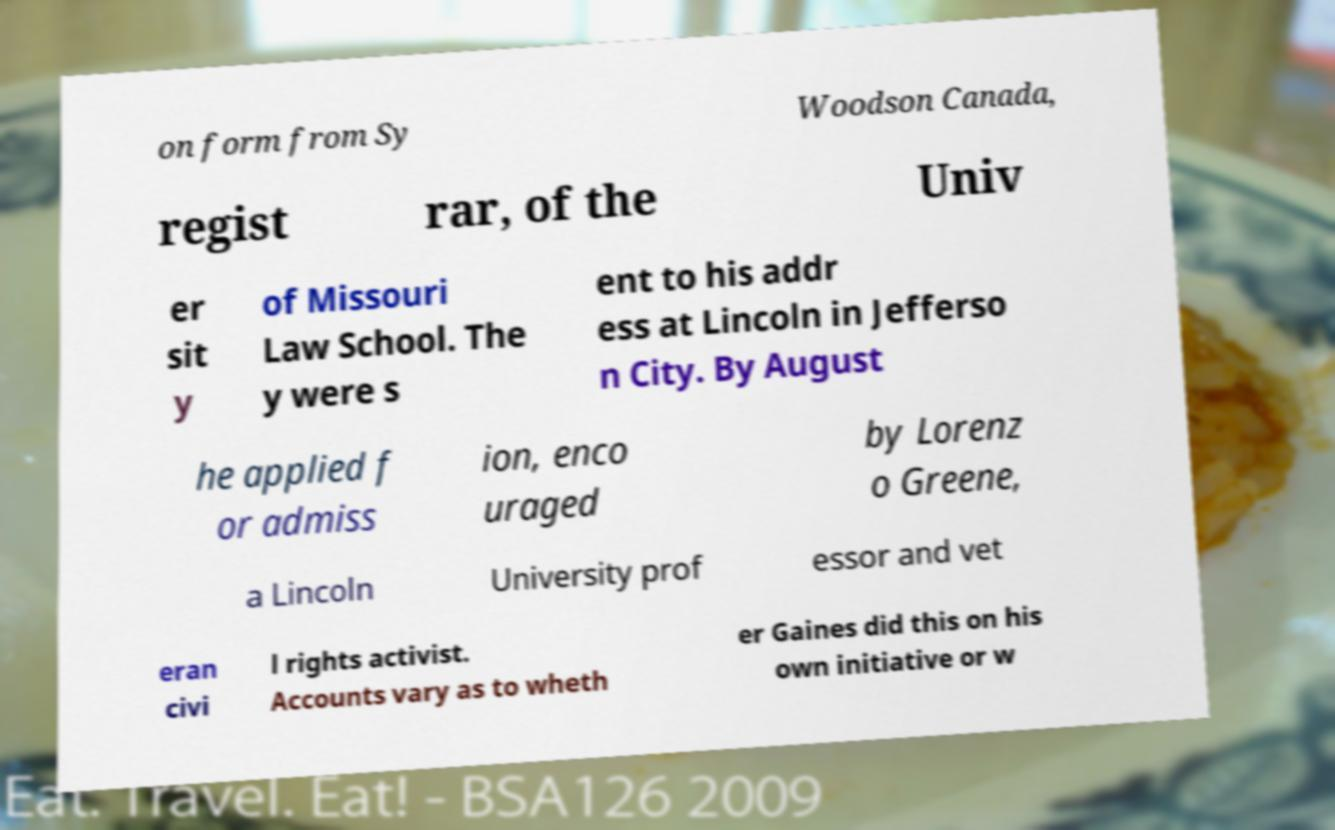There's text embedded in this image that I need extracted. Can you transcribe it verbatim? on form from Sy Woodson Canada, regist rar, of the Univ er sit y of Missouri Law School. The y were s ent to his addr ess at Lincoln in Jefferso n City. By August he applied f or admiss ion, enco uraged by Lorenz o Greene, a Lincoln University prof essor and vet eran civi l rights activist. Accounts vary as to wheth er Gaines did this on his own initiative or w 